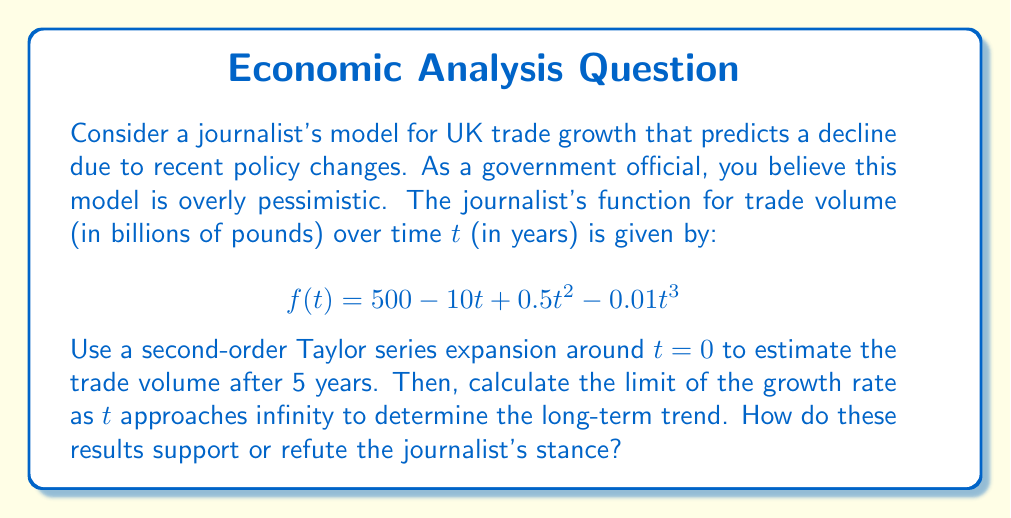Can you answer this question? 1) First, let's find the second-order Taylor series expansion of $f(t)$ around $t=0$:

   $$f(t) \approx f(0) + f'(0)t + \frac{f''(0)}{2!}t^2$$

2) Calculate the derivatives:
   $$f'(t) = -10 + t - 0.03t^2$$
   $$f''(t) = 1 - 0.06t$$

3) Evaluate at $t=0$:
   $$f(0) = 500$$
   $$f'(0) = -10$$
   $$f''(0) = 1$$

4) Substitute into the Taylor series:
   $$f(t) \approx 500 - 10t + \frac{1}{2}t^2$$

5) To estimate the trade volume after 5 years, substitute $t=5$:
   $$f(5) \approx 500 - 10(5) + \frac{1}{2}(5)^2 = 500 - 50 + 12.5 = 462.5$$

6) For the long-term trend, we need to find the limit of the growth rate as $t$ approaches infinity:
   $$\lim_{t \to \infty} \frac{f'(t)}{f(t)} = \lim_{t \to \infty} \frac{-10 + t - 0.03t^2}{500 - 10t + 0.5t^2 - 0.01t^3}$$

7) Dividing numerator and denominator by the highest power of $t$ ($t^3$):
   $$\lim_{t \to \infty} \frac{-10/t^3 + 1/t^2 - 0.03/t}{500/t^3 - 10/t^2 + 0.5/t - 0.01} = \frac{0}{-0.01} = 0$$

8) The limit being 0 indicates that the growth rate approaches 0 in the long term, suggesting stability rather than decline.

These results refute the journalist's stance of a declining trade volume. The 5-year estimate shows only a slight decrease from the initial 500 billion pounds, and the long-term trend suggests stability rather than continued decline.
Answer: Taylor estimate at 5 years: 462.5 billion pounds. Long-term growth rate limit: 0. Results refute journalist's declining trade prediction. 